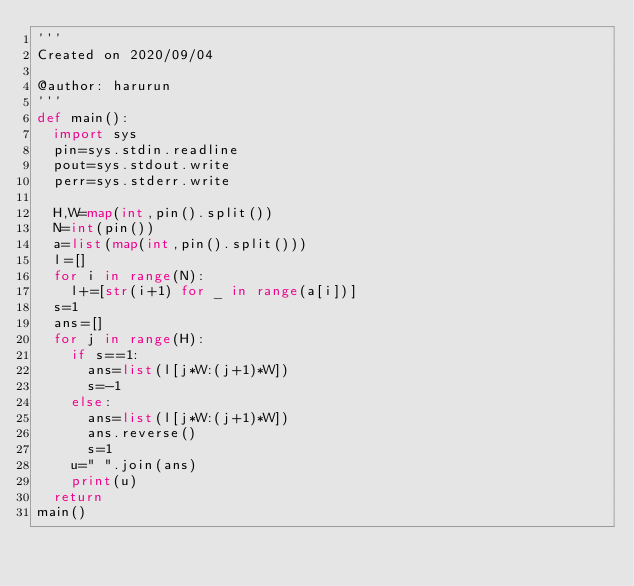<code> <loc_0><loc_0><loc_500><loc_500><_Python_>'''
Created on 2020/09/04

@author: harurun
'''
def main():
  import sys
  pin=sys.stdin.readline
  pout=sys.stdout.write
  perr=sys.stderr.write

  H,W=map(int,pin().split())
  N=int(pin())
  a=list(map(int,pin().split()))
  l=[]
  for i in range(N):
    l+=[str(i+1) for _ in range(a[i])]
  s=1
  ans=[]
  for j in range(H):
    if s==1:
      ans=list(l[j*W:(j+1)*W])
      s=-1
    else:
      ans=list(l[j*W:(j+1)*W])
      ans.reverse()
      s=1
    u=" ".join(ans)
    print(u)
  return 
main()</code> 